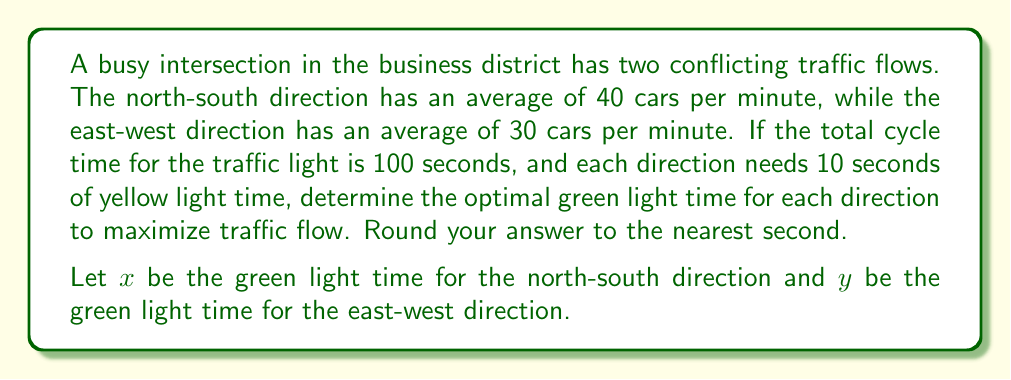Teach me how to tackle this problem. 1) First, we need to set up an equation for the total cycle time:
   $$x + y + 20 = 100$$
   (20 seconds accounts for the yellow light time in both directions)

2) We want to maximize the total number of cars that can pass through the intersection during one cycle. This can be represented by the equation:
   $$40 \cdot \frac{x}{60} + 30 \cdot \frac{y}{60}$$
   (Where $\frac{x}{60}$ and $\frac{y}{60}$ convert seconds to minutes)

3) Simplify the maximization equation:
   $$\frac{2x}{3} + \frac{y}{2}$$

4) Use the cycle time equation to express y in terms of x:
   $$y = 80 - x$$

5) Substitute this into the maximization equation:
   $$\frac{2x}{3} + \frac{80-x}{2} = \frac{2x}{3} + 40 - \frac{x}{2}$$

6) Simplify:
   $$\frac{4x}{6} + 40 - \frac{3x}{6} = \frac{x}{6} + 40$$

7) To find the maximum, differentiate with respect to x and set to zero:
   $$\frac{d}{dx}(\frac{x}{6} + 40) = \frac{1}{6} = 0$$

8) This shows that the function increases linearly with x, so the maximum occurs at the largest possible value of x.

9) The largest possible value of x is when y is at its minimum (which is 10 seconds, the yellow light time):
   $$x + 10 + 20 = 100$$
   $$x = 70$$

10) Therefore, the optimal green light times are:
    North-South (x): 70 seconds
    East-West (y): 10 seconds
Answer: North-South: 70 seconds, East-West: 10 seconds 